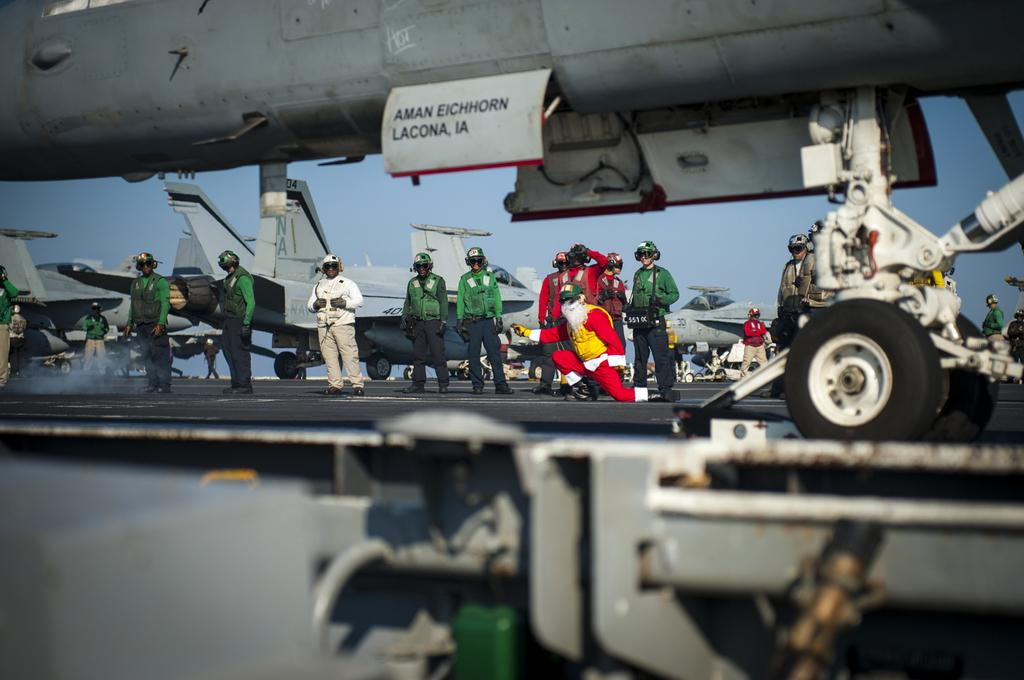What are the people in the image doing? The persons in the image are standing on the ground. What is the main subject in the image? There is a huge aircraft in the image. Are there any other aircrafts visible besides the main one? Yes, there are other aircrafts visible in the background. What can be seen in the sky in the image? The sky is visible in the image. What type of beast can be seen moving around in the yard in the image? There is no beast or yard present in the image; it features people standing on the ground and aircrafts. 